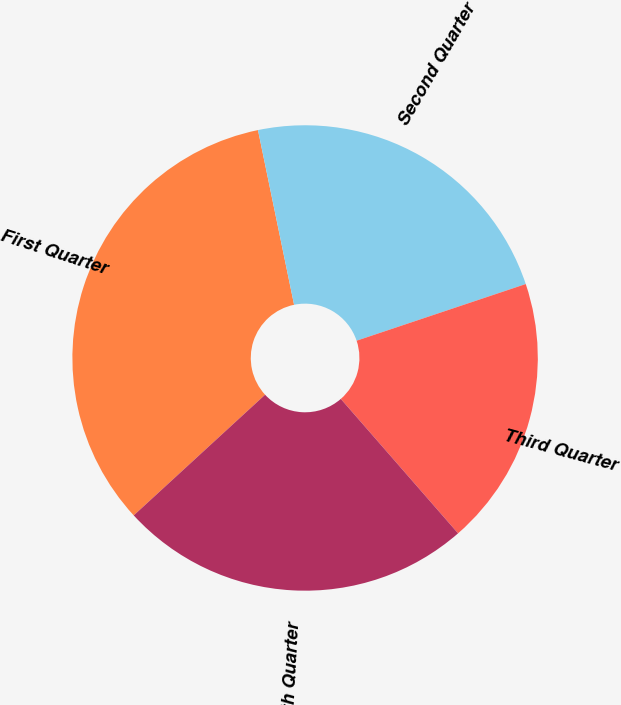Convert chart to OTSL. <chart><loc_0><loc_0><loc_500><loc_500><pie_chart><fcel>First Quarter<fcel>Second Quarter<fcel>Third Quarter<fcel>Fourth Quarter<nl><fcel>33.58%<fcel>23.1%<fcel>18.73%<fcel>24.59%<nl></chart> 